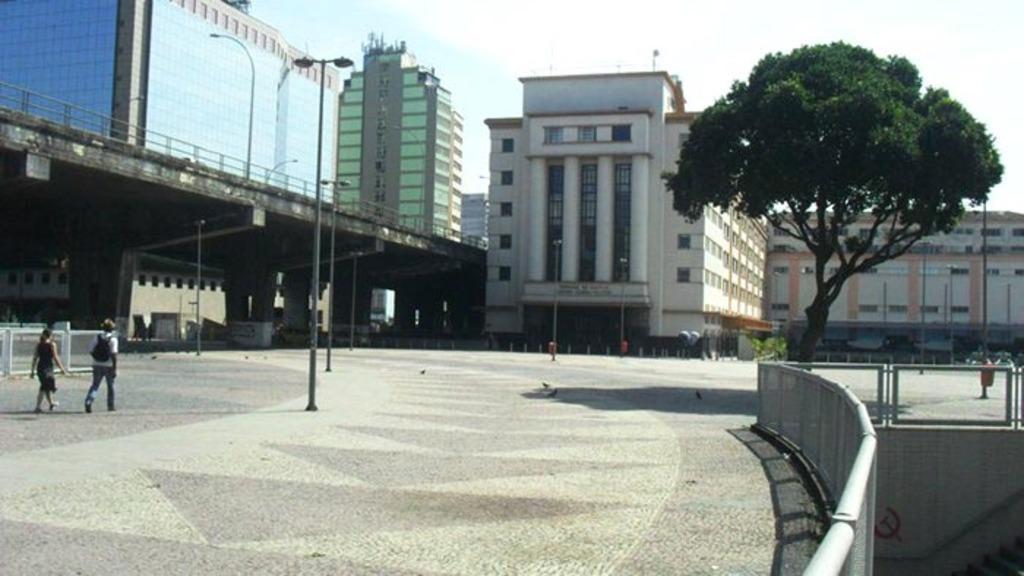In one or two sentences, can you explain what this image depicts? In this image on the left, there is a man, he wears a t shirt, trouser and bag, he is walking and there is a woman, she is walking. In the background there are buildings, street lights, bridge, trees and sky. 